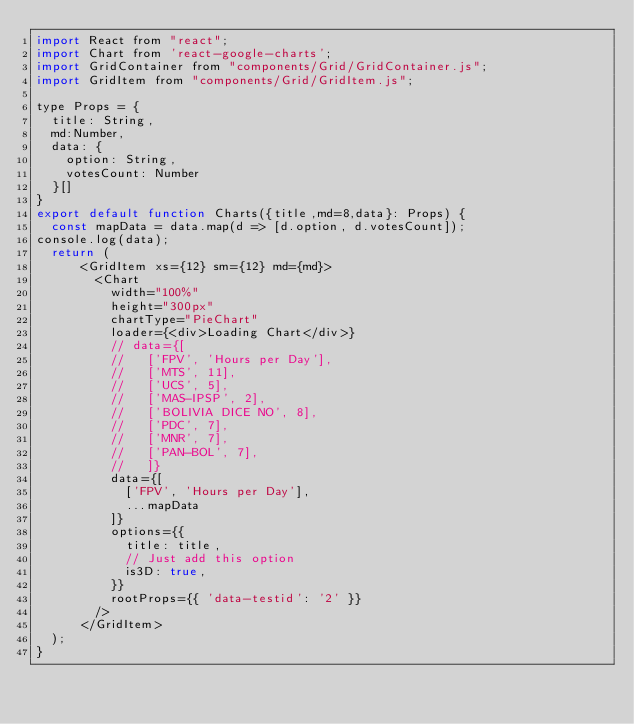<code> <loc_0><loc_0><loc_500><loc_500><_JavaScript_>import React from "react";
import Chart from 'react-google-charts';
import GridContainer from "components/Grid/GridContainer.js";
import GridItem from "components/Grid/GridItem.js";

type Props = {
  title: String,
  md:Number,
  data: {
    option: String,
    votesCount: Number
  }[]
}
export default function Charts({title,md=8,data}: Props) {
  const mapData = data.map(d => [d.option, d.votesCount]);
console.log(data);
  return (
      <GridItem xs={12} sm={12} md={md}>
        <Chart
          width="100%"
          height="300px"
          chartType="PieChart"
          loader={<div>Loading Chart</div>}
          // data={[
          //   ['FPV', 'Hours per Day'],
          //   ['MTS', 11],
          //   ['UCS', 5],
          //   ['MAS-IPSP', 2],
          //   ['BOLIVIA DICE NO', 8],
          //   ['PDC', 7],
          //   ['MNR', 7],
          //   ['PAN-BOL', 7],
          //   ]}
          data={[
            ['FPV', 'Hours per Day'],
            ...mapData
          ]}
          options={{
            title: title,
            // Just add this option
            is3D: true,
          }}
          rootProps={{ 'data-testid': '2' }}
        />
      </GridItem>
  );
}
</code> 